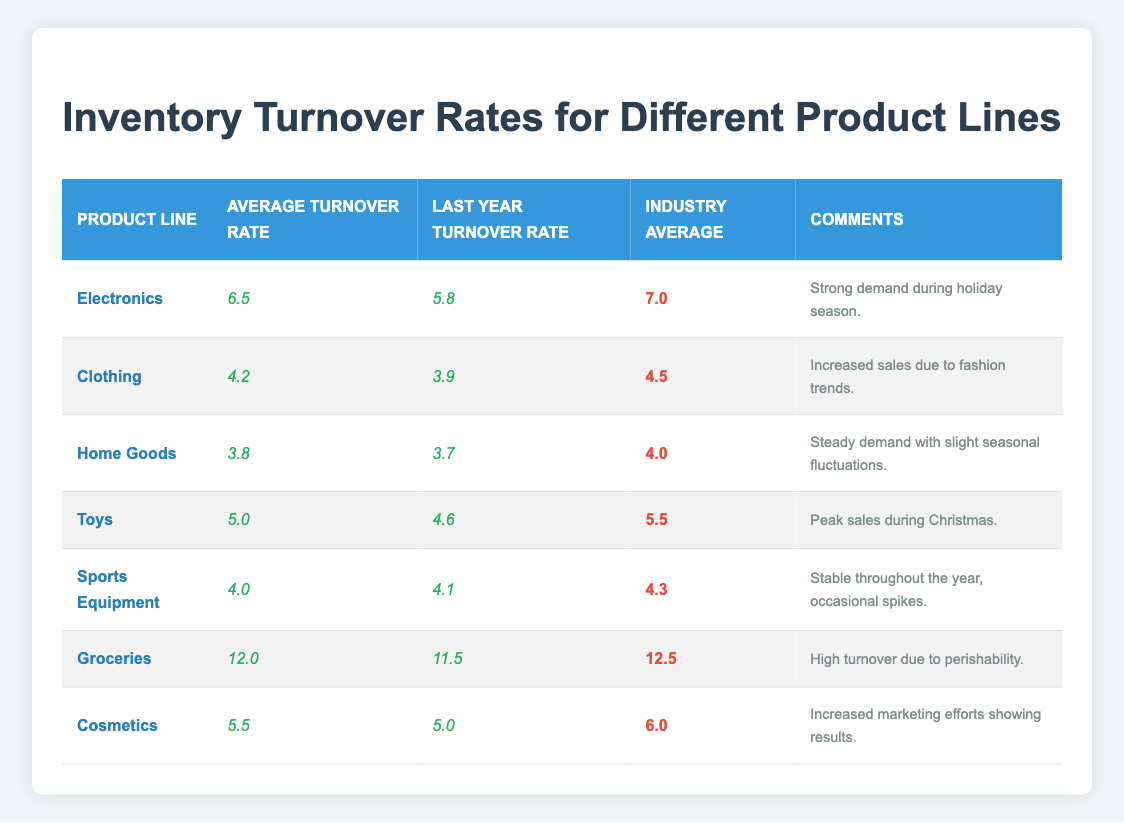What's the average turnover rate for Electronics? The average turnover rate for Electronics is listed directly in the table as 6.5.
Answer: 6.5 What was the last year's turnover rate for Clothing? The last year turnover rate for Clothing is clearly stated in the table as 3.9.
Answer: 3.9 Which product line has the highest inventory turnover rate? Looking through the average turnover rates, Groceries has the highest rate at 12.0.
Answer: Groceries Is the average turnover rate for Home Goods above the industry average? The average turnover rate for Home Goods is 3.8, while the industry average is 4.0, making it lower than the industry average.
Answer: No Calculate the difference between the average turnover rates of Toys and Sports Equipment. The average turnover rate for Toys is 5.0 and for Sports Equipment is 4.0, so the difference is 5.0 - 4.0 = 1.0.
Answer: 1.0 What was the comment regarding the performance of Cosmetics? The comment for Cosmetics states, "Increased marketing efforts showing results." This is noted directly in the table.
Answer: Increased marketing efforts showing results Did any product line exceed its industry average in turnover rate? Comparing the average turnover rates with the industry averages, only Electronics (6.5) and Cosmetics (5.5) come close but do not exceed their respective industry averages of 7.0 and 6.0.
Answer: No Which product line showed the most significant improvement from last year to this year? The last year's turnover rate for Clothing was 3.9, and this year it's 4.2, showing an improvement of 0.3. This is the highest increase compared to other product lines.
Answer: Clothing What can be inferred about the Groceries turnover in relation to perishability? The table comments that Groceries have a high turnover due to perishability, and it has an average turnover rate of 12.0, which is quite high. This indicates a correlation between perishability and turnover rates.
Answer: High turnover due to perishability Which product line came closest to matching its industry average? Sports Equipment has an average turnover rate of 4.0, which is close to the industry average of 4.3, with a difference of 0.3.
Answer: Sports Equipment 